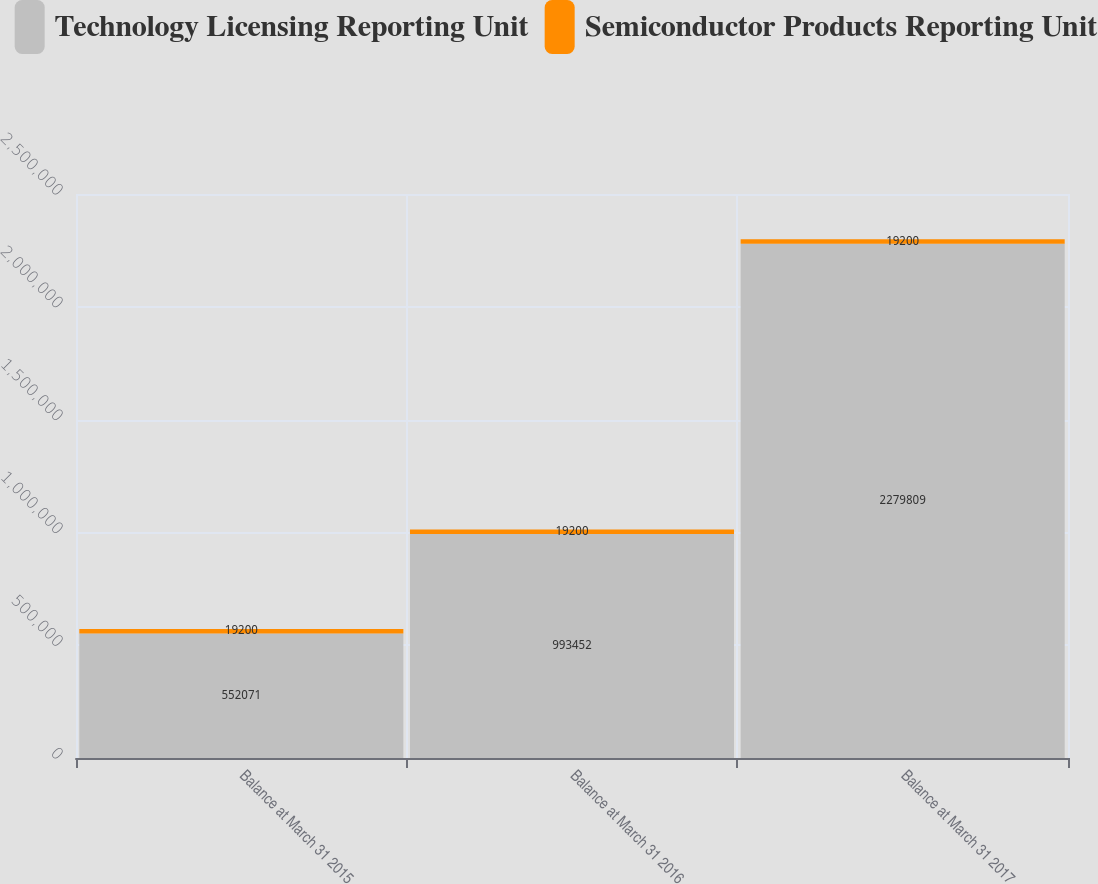<chart> <loc_0><loc_0><loc_500><loc_500><stacked_bar_chart><ecel><fcel>Balance at March 31 2015<fcel>Balance at March 31 2016<fcel>Balance at March 31 2017<nl><fcel>Technology Licensing Reporting Unit<fcel>552071<fcel>993452<fcel>2.27981e+06<nl><fcel>Semiconductor Products Reporting Unit<fcel>19200<fcel>19200<fcel>19200<nl></chart> 